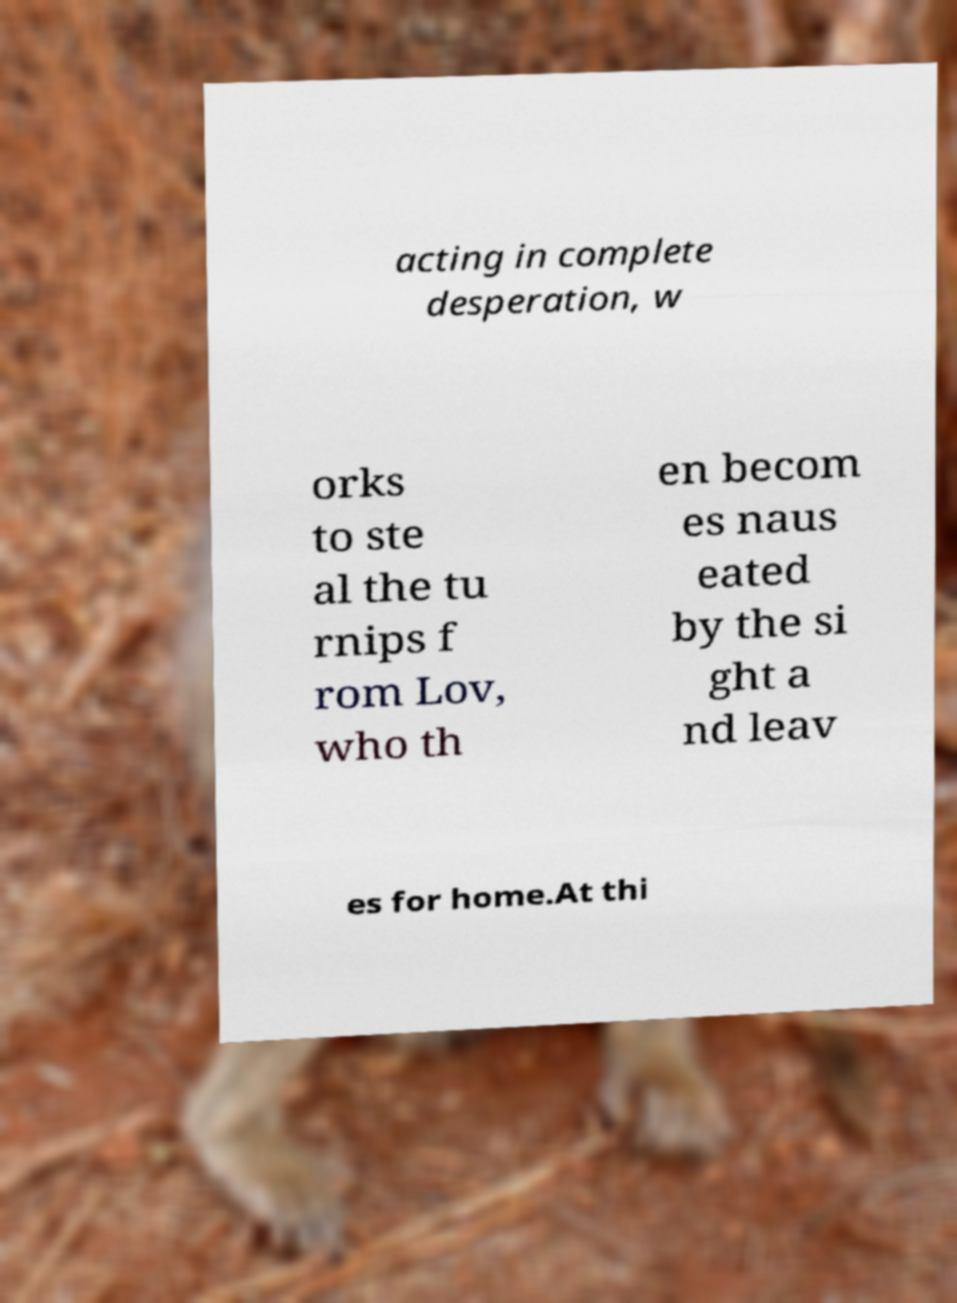What messages or text are displayed in this image? I need them in a readable, typed format. acting in complete desperation, w orks to ste al the tu rnips f rom Lov, who th en becom es naus eated by the si ght a nd leav es for home.At thi 